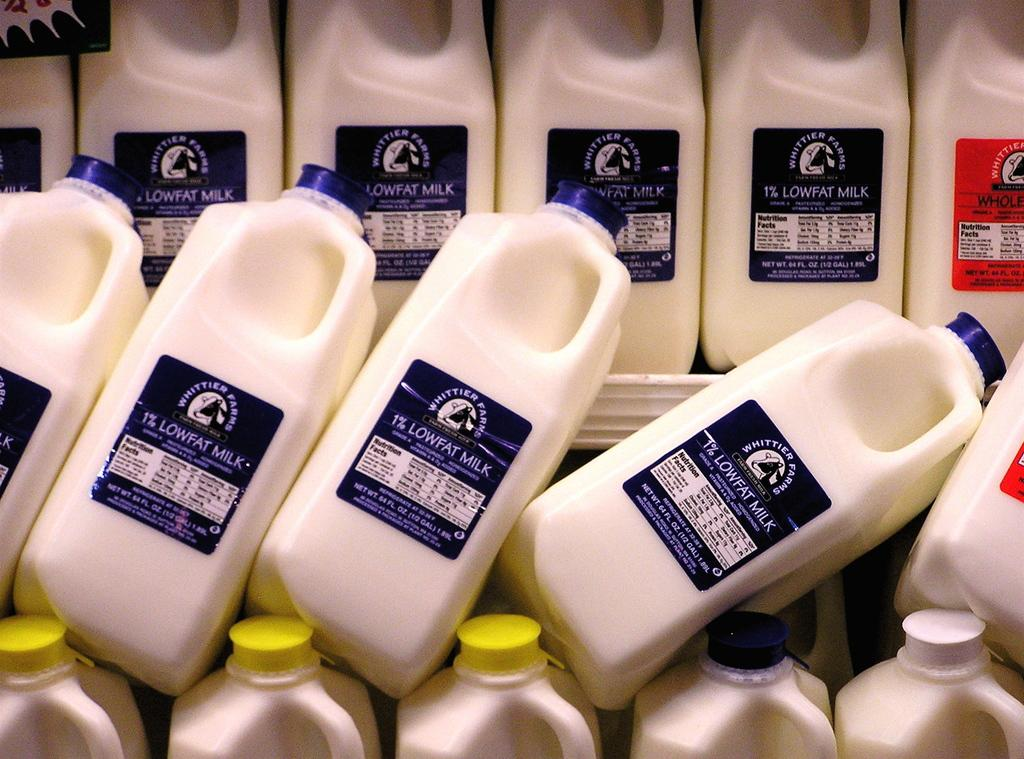<image>
Render a clear and concise summary of the photo. Many cartons in the half gallon selection and made by Whittier farms are on display. 